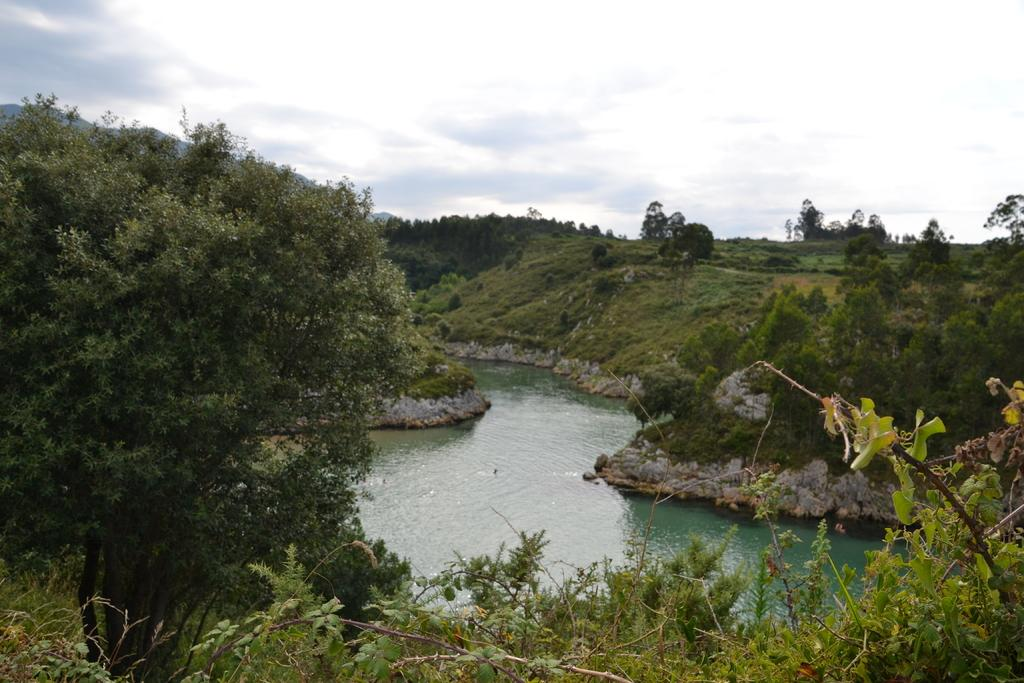What type of natural feature is present in the image? There is a river in the image. What other natural elements can be seen in the image? There are plants, trees, and grass in the image. Where is the store located in the image? There is no store present in the image; it features natural elements such as a river, plants, trees, and grass. What type of cap is the uncle wearing in the image? There is no uncle or cap present in the image. 